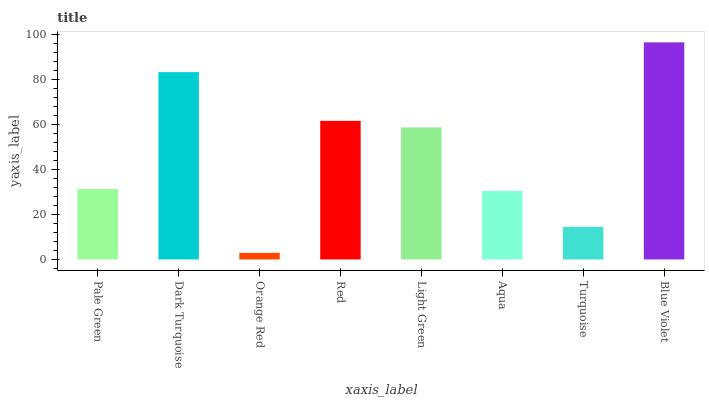Is Dark Turquoise the minimum?
Answer yes or no. No. Is Dark Turquoise the maximum?
Answer yes or no. No. Is Dark Turquoise greater than Pale Green?
Answer yes or no. Yes. Is Pale Green less than Dark Turquoise?
Answer yes or no. Yes. Is Pale Green greater than Dark Turquoise?
Answer yes or no. No. Is Dark Turquoise less than Pale Green?
Answer yes or no. No. Is Light Green the high median?
Answer yes or no. Yes. Is Pale Green the low median?
Answer yes or no. Yes. Is Orange Red the high median?
Answer yes or no. No. Is Aqua the low median?
Answer yes or no. No. 